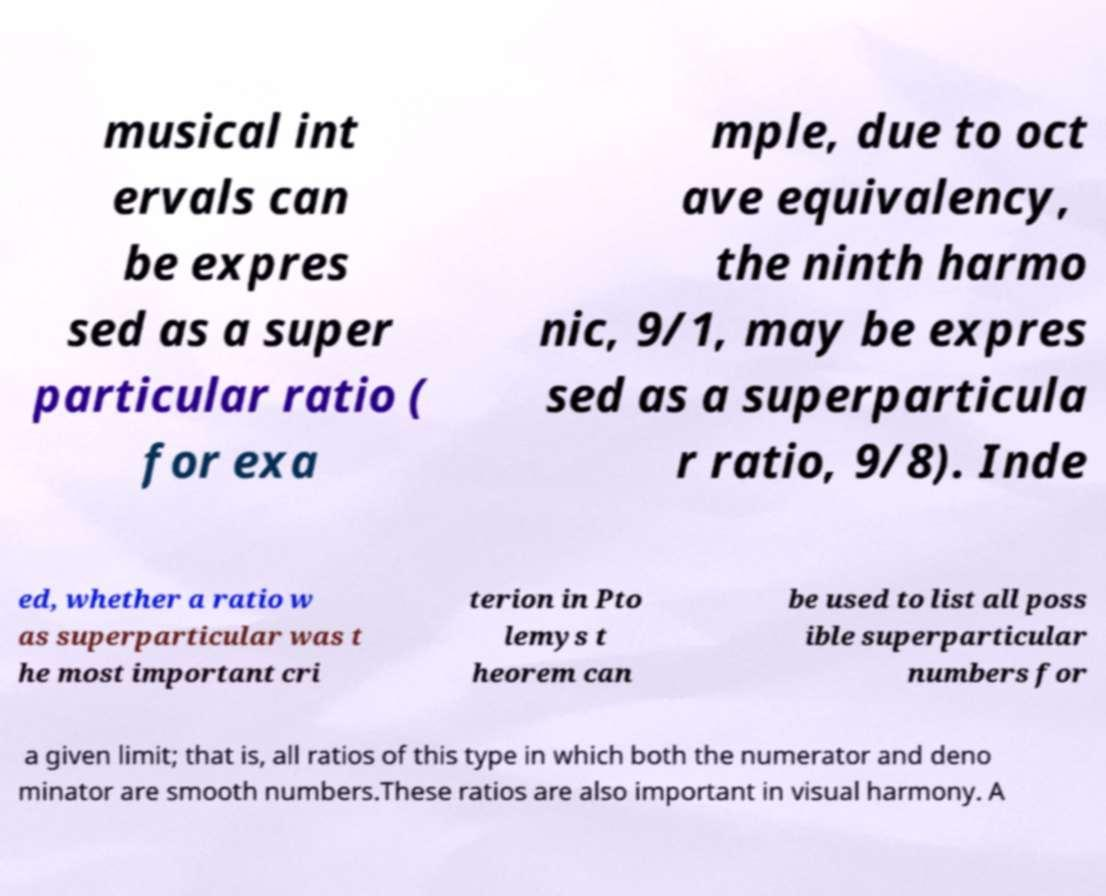What messages or text are displayed in this image? I need them in a readable, typed format. musical int ervals can be expres sed as a super particular ratio ( for exa mple, due to oct ave equivalency, the ninth harmo nic, 9/1, may be expres sed as a superparticula r ratio, 9/8). Inde ed, whether a ratio w as superparticular was t he most important cri terion in Pto lemys t heorem can be used to list all poss ible superparticular numbers for a given limit; that is, all ratios of this type in which both the numerator and deno minator are smooth numbers.These ratios are also important in visual harmony. A 